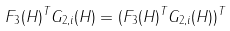Convert formula to latex. <formula><loc_0><loc_0><loc_500><loc_500>F _ { 3 } ( H ) ^ { T } G _ { 2 , i } ( H ) = ( F _ { 3 } ( H ) ^ { T } G _ { 2 , i } ( H ) ) ^ { T }</formula> 